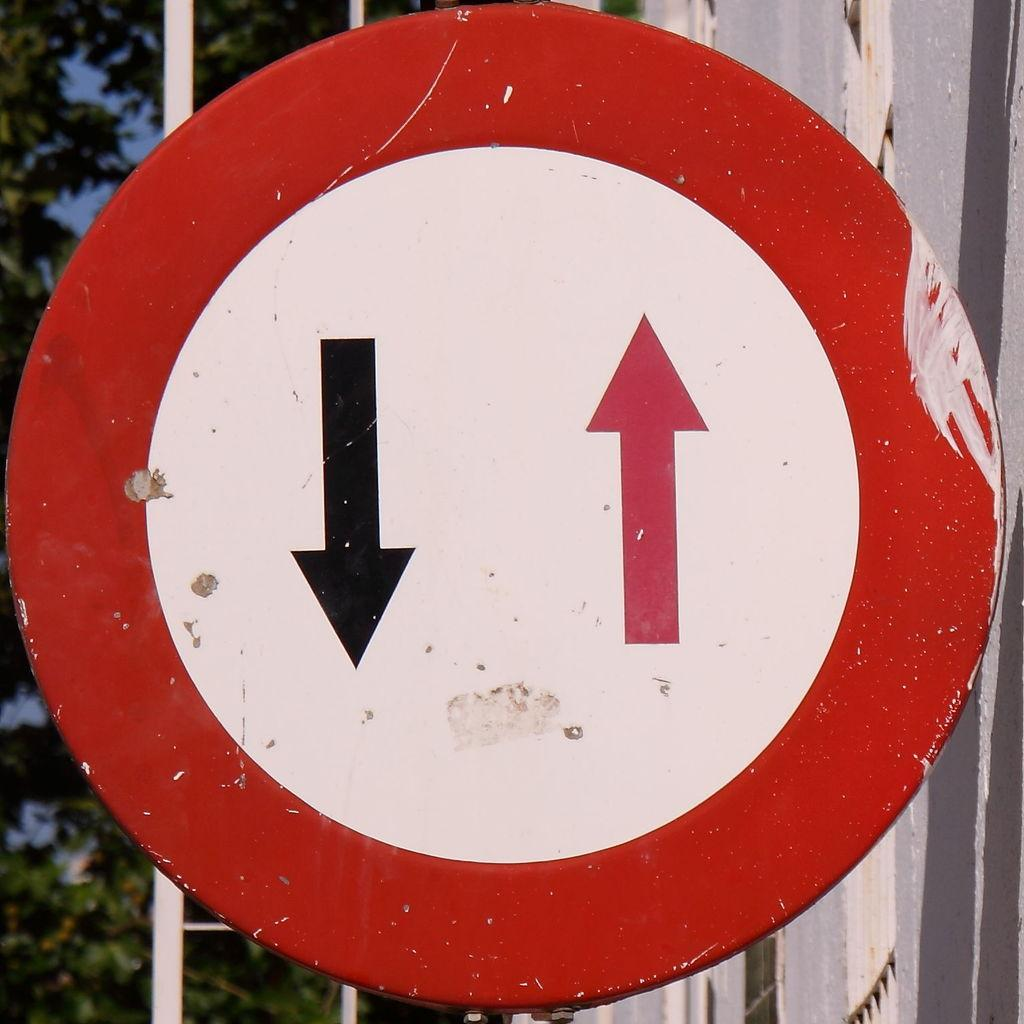What is the main object in the foreground of the image? There is a signboard in the image. What can be seen in the distance behind the signboard? There are roads and trees visible in the background of the image. Are there any other objects or structures visible in the background? Yes, there are other objects present in the background of the image. What type of belief is being expressed on the signboard in the image? There is no indication of any belief being expressed on the signboard in the image. Is there a bomb visible in the image? No, there is no bomb present in the image. 